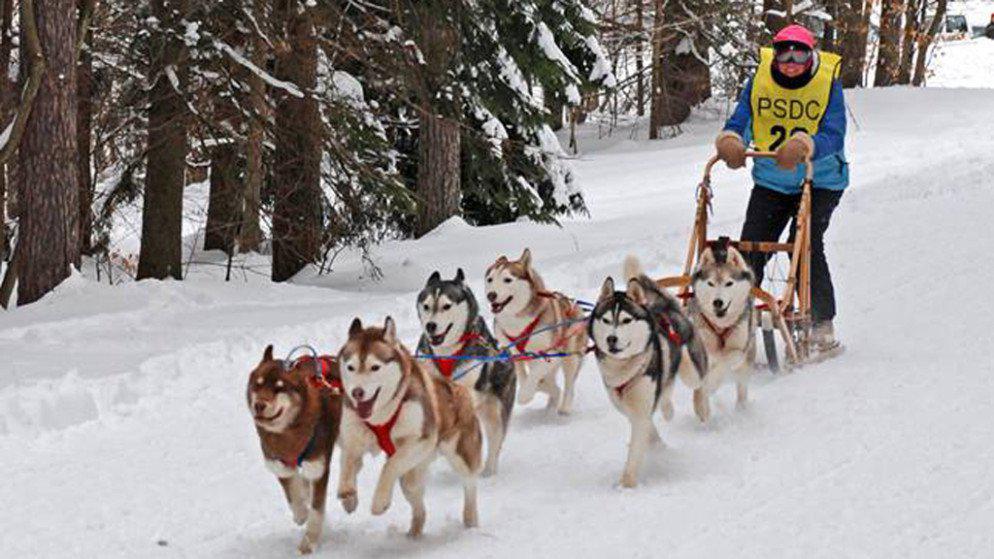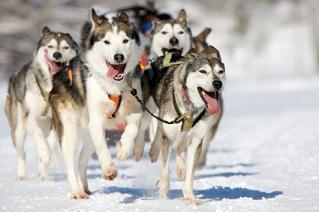The first image is the image on the left, the second image is the image on the right. Examine the images to the left and right. Is the description "There is snow on the trees in one of the images." accurate? Answer yes or no. Yes. 